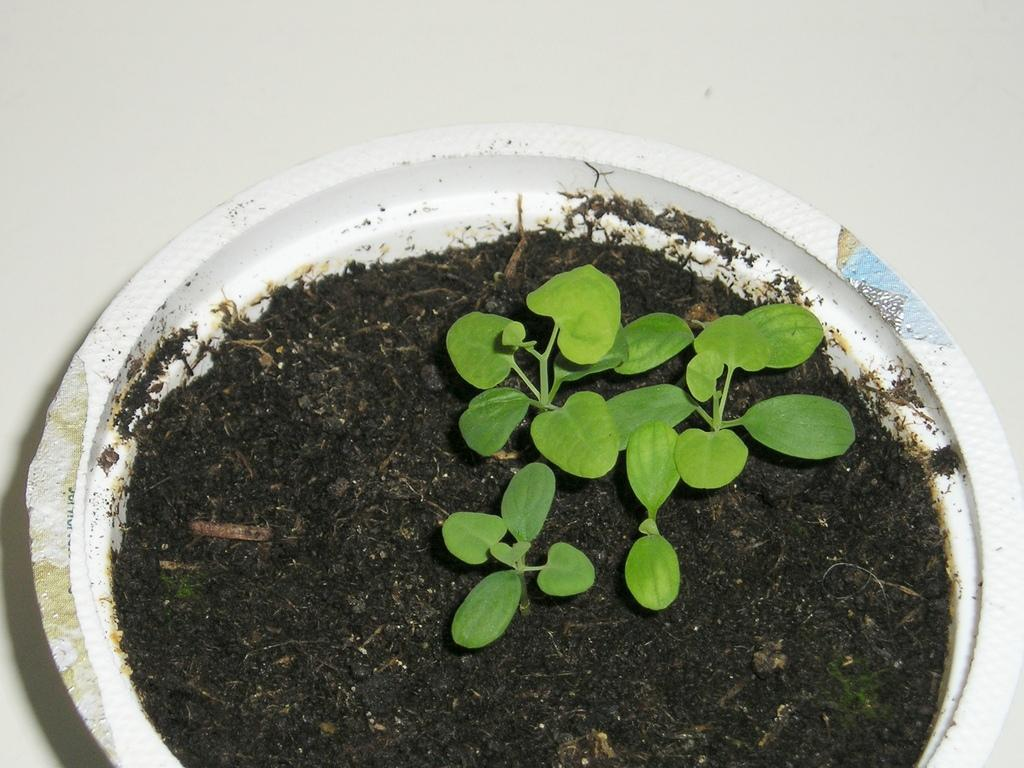What is the main subject of the image? There is a houseplant in the center of the image. Can you describe the houseplant in more detail? Unfortunately, the image does not provide enough detail to describe the houseplant further. How many sisters are depicted in the image? There are no sisters present in the image; it only features a houseplant. What type of quilt is covering the houseplant in the image? There is no quilt present in the image; it only features a houseplant. 